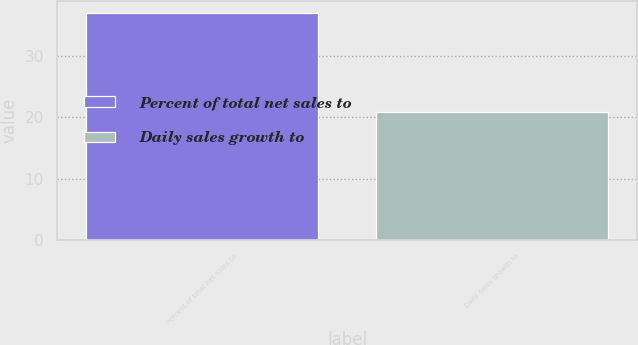Convert chart. <chart><loc_0><loc_0><loc_500><loc_500><bar_chart><fcel>Percent of total net sales to<fcel>Daily sales growth to<nl><fcel>37<fcel>20.9<nl></chart> 